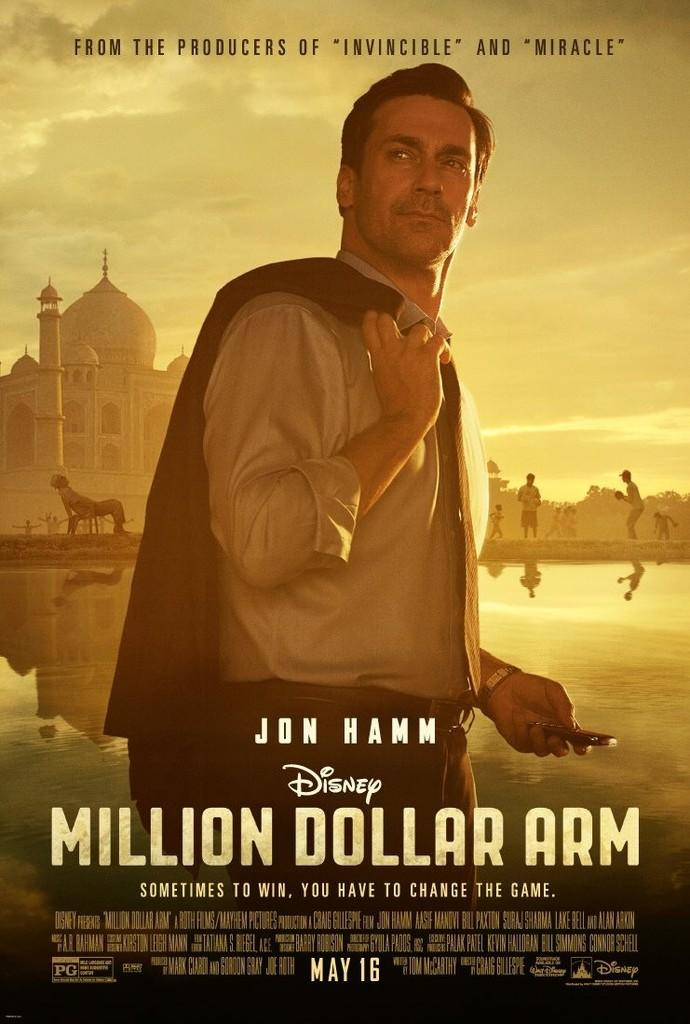What is the person in the image doing? The person is standing in the image and holding a suit in his hand. Are there any other people in the image? Yes, there are people behind the person. What famous landmark can be seen in the image? The Taj Mahal is visible in the left corner of the image. What is written below the Taj Mahal? There is something written below the Taj Mahal, but we cannot determine the exact text from the image. What type of honey can be seen dripping from the watch in the image? There is no watch or honey present in the image. 